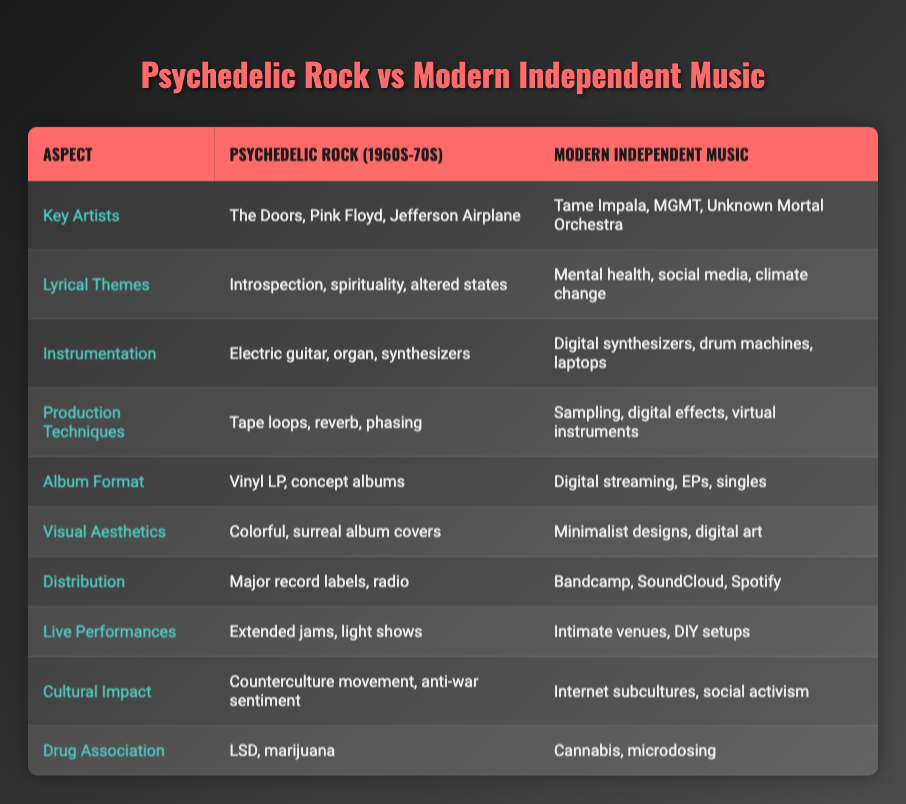What are some key artists in psychedelic rock? The table explicitly lists "The Doors, Pink Floyd, Jefferson Airplane" under the column for Psychedelic Rock (1960s-70s).
Answer: The Doors, Pink Floyd, Jefferson Airplane What are the lyrical themes present in modern independent music? It can be found in the table that "Mental health, social media, climate change" are the listed themes under Modern Independent Music.
Answer: Mental health, social media, climate change Is the use of digital synthesizers a characteristic of psychedelic rock? The table shows that "Electric guitar, organ, synthesizers" are used in Psychedelic Rock, while "Digital synthesizers" is mentioned for Modern Independent Music, indicating that digital synthesizers are not a characteristic of psychedelic rock.
Answer: No Which genre has a stronger association with drugs, psychedelic rock or modern independent music? The table indicates "LSD, marijuana" for psychedelic rock and "Cannabis, microdosing" for modern independent music, but both genres have a drug association, so the question is subjective.
Answer: Both genres have a drug association What are the primary production techniques used in modern independent music compared to psychedelic rock? The table shows "Tape loops, reverb, phasing" for psychedelic rock and "Sampling, digital effects, virtual instruments" for modern independent music, highlighting a shift from analog to digital production methods.
Answer: Sampling, digital effects, virtual instruments Compare the cultural impacts of both genres. The table lists "Counterculture movement, anti-war sentiment" for psychedelic rock and "Internet subcultures, social activism" for modern independent music, which indicates that each genre has influenced social movements in its own context.
Answer: Different kinds of social movements What types of album formats are used in modern independent music versus psychedelic rock? The table displays "Vinyl LP, concept albums" for psychedelic rock and "Digital streaming, EPs, singles" for modern independent music, showing how the formats have evolved with technology and distribution methods.
Answer: Digital streaming, EPs, singles How would you contrast the visual aesthetics of both genres? The aesthetic for psychedelic rock is described as "Colorful, surreal album covers," while modern independent music is described as "Minimalist designs, digital art," indicating a shift from elaborate visuals to minimalist approaches.
Answer: Colorful, surreal versus minimalist designs Are extended jams a common feature in modern independent music? The table presents "Extended jams, light shows" under psychedelic rock, while modern independent music features "Intimate venues, DIY setups," suggesting that extended jams are not a common feature today.
Answer: No 